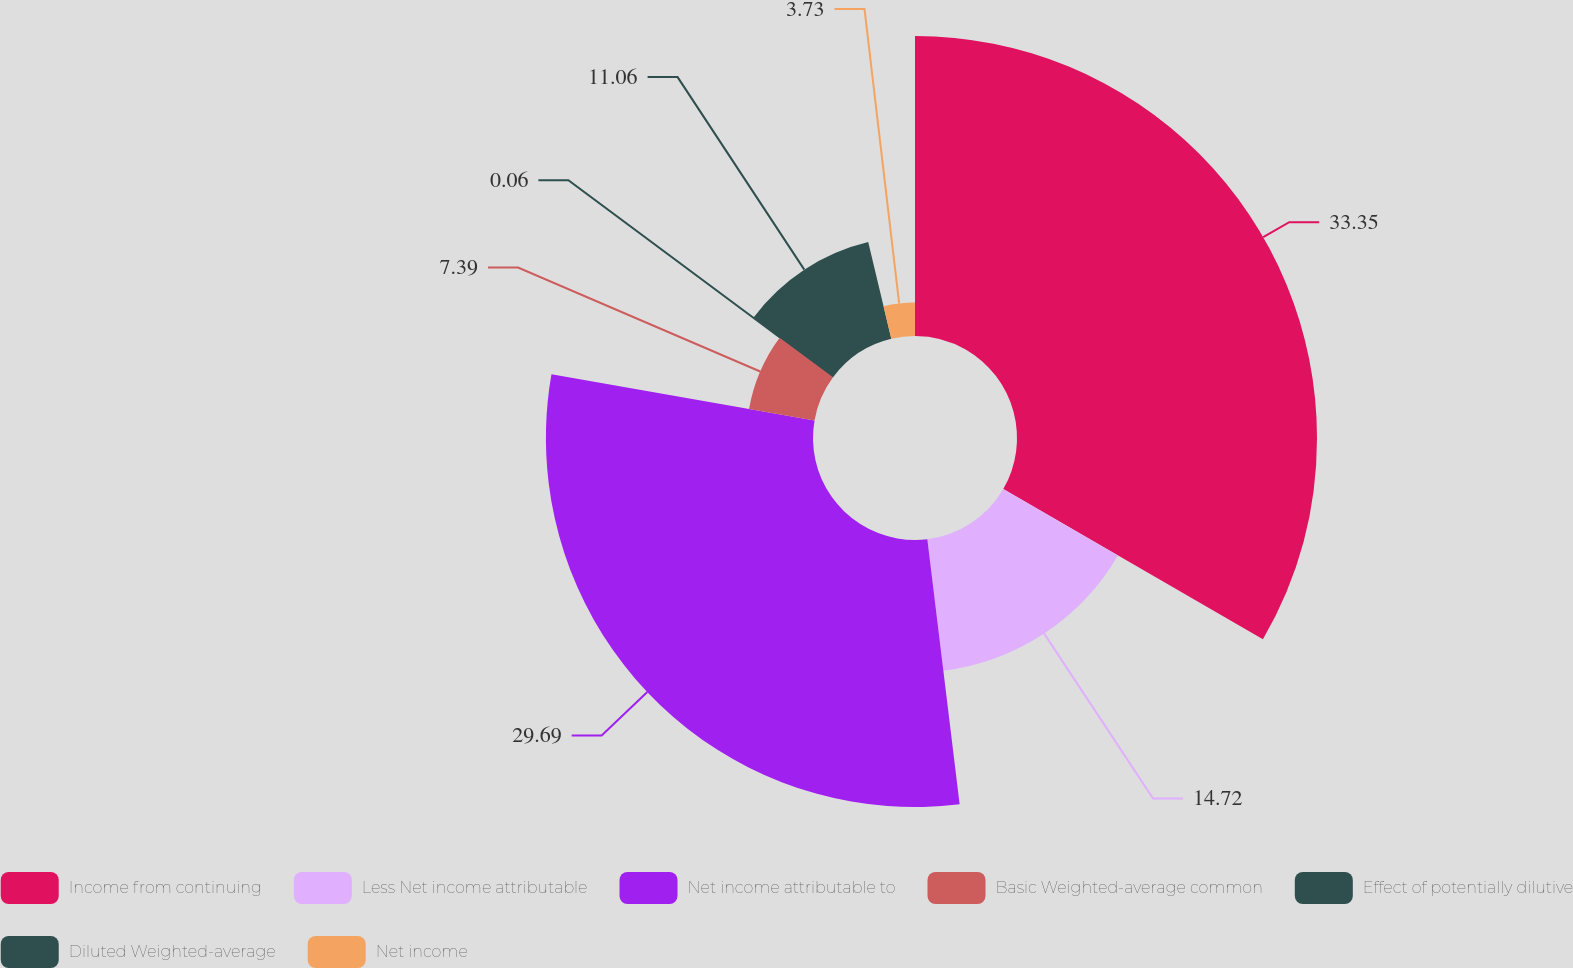Convert chart. <chart><loc_0><loc_0><loc_500><loc_500><pie_chart><fcel>Income from continuing<fcel>Less Net income attributable<fcel>Net income attributable to<fcel>Basic Weighted-average common<fcel>Effect of potentially dilutive<fcel>Diluted Weighted-average<fcel>Net income<nl><fcel>33.35%<fcel>14.72%<fcel>29.69%<fcel>7.39%<fcel>0.06%<fcel>11.06%<fcel>3.73%<nl></chart> 